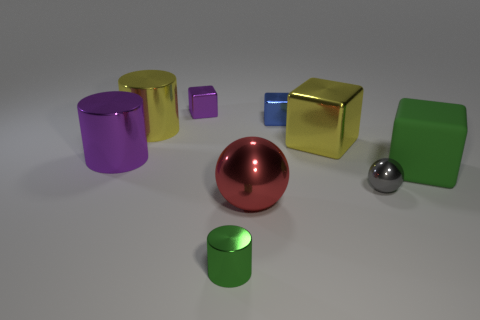Subtract 1 cubes. How many cubes are left? 3 Add 1 rubber things. How many objects exist? 10 Subtract all cylinders. How many objects are left? 6 Subtract all large cyan metallic cylinders. Subtract all cylinders. How many objects are left? 6 Add 8 big yellow cubes. How many big yellow cubes are left? 9 Add 8 small red matte cylinders. How many small red matte cylinders exist? 8 Subtract 0 green spheres. How many objects are left? 9 